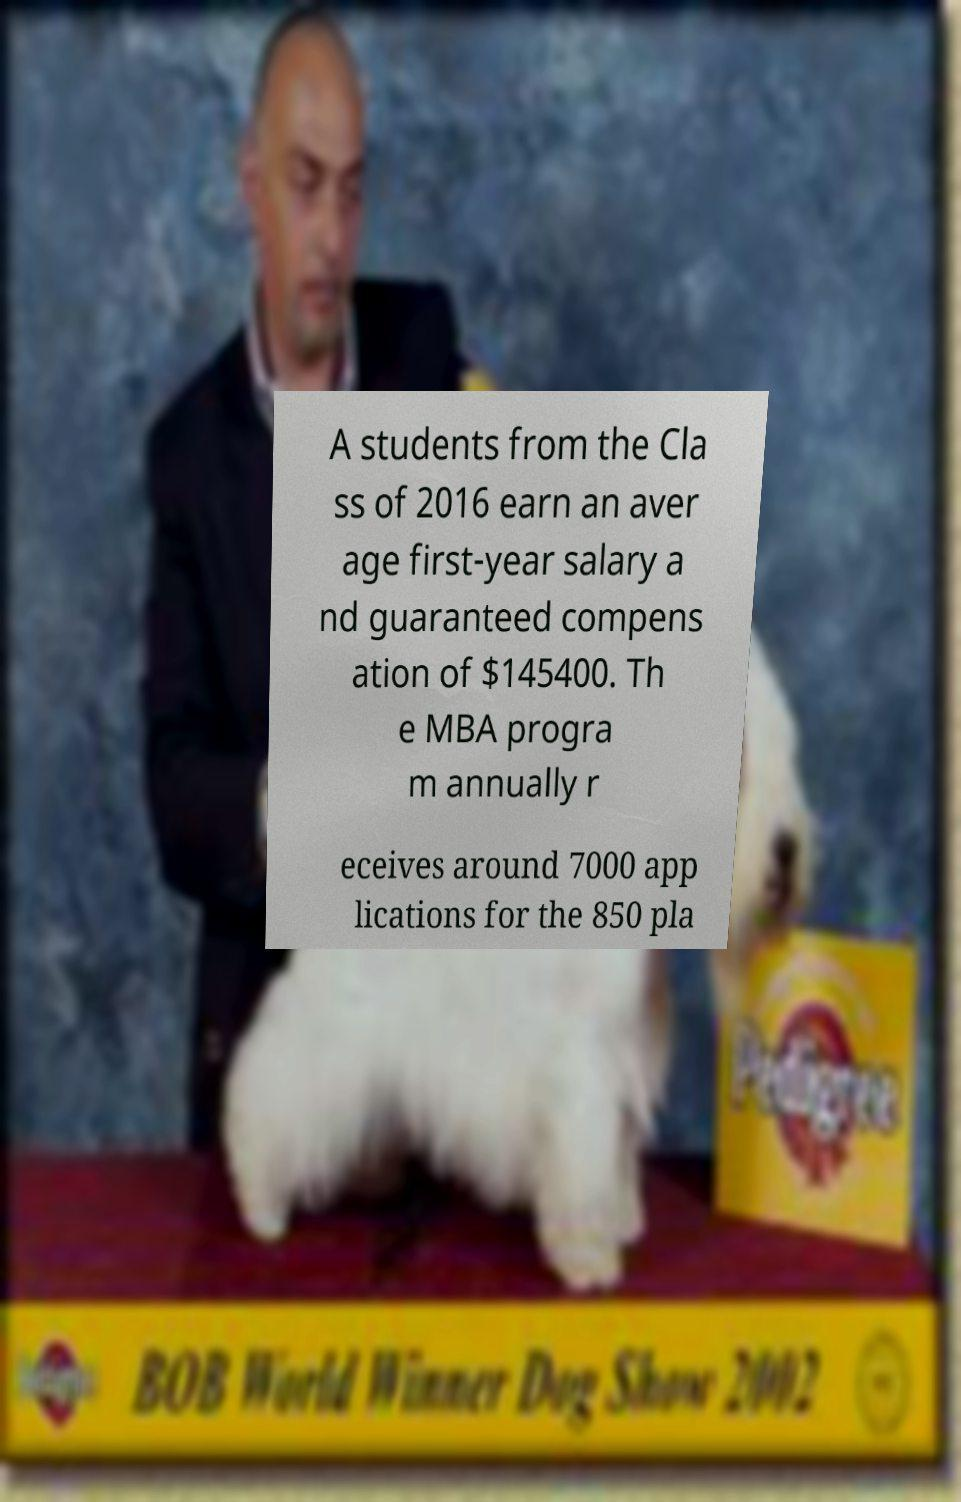What messages or text are displayed in this image? I need them in a readable, typed format. A students from the Cla ss of 2016 earn an aver age first-year salary a nd guaranteed compens ation of $145400. Th e MBA progra m annually r eceives around 7000 app lications for the 850 pla 